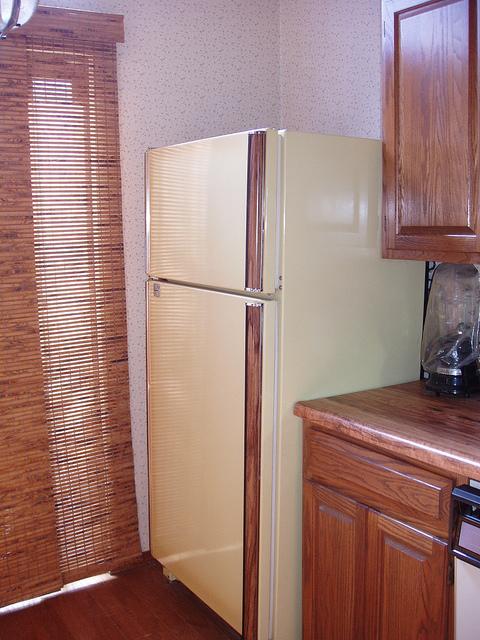What color is the refrigerator?
Concise answer only. White. What wood are the cabinets made of?
Concise answer only. Oak. What room is this?
Be succinct. Kitchen. 